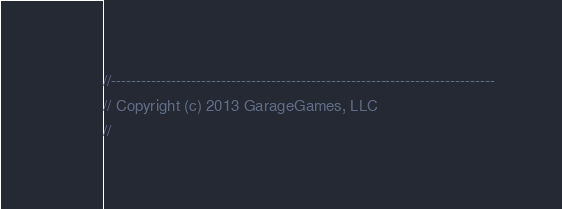Convert code to text. <code><loc_0><loc_0><loc_500><loc_500><_ObjectiveC_>//-----------------------------------------------------------------------------
// Copyright (c) 2013 GarageGames, LLC
//</code> 